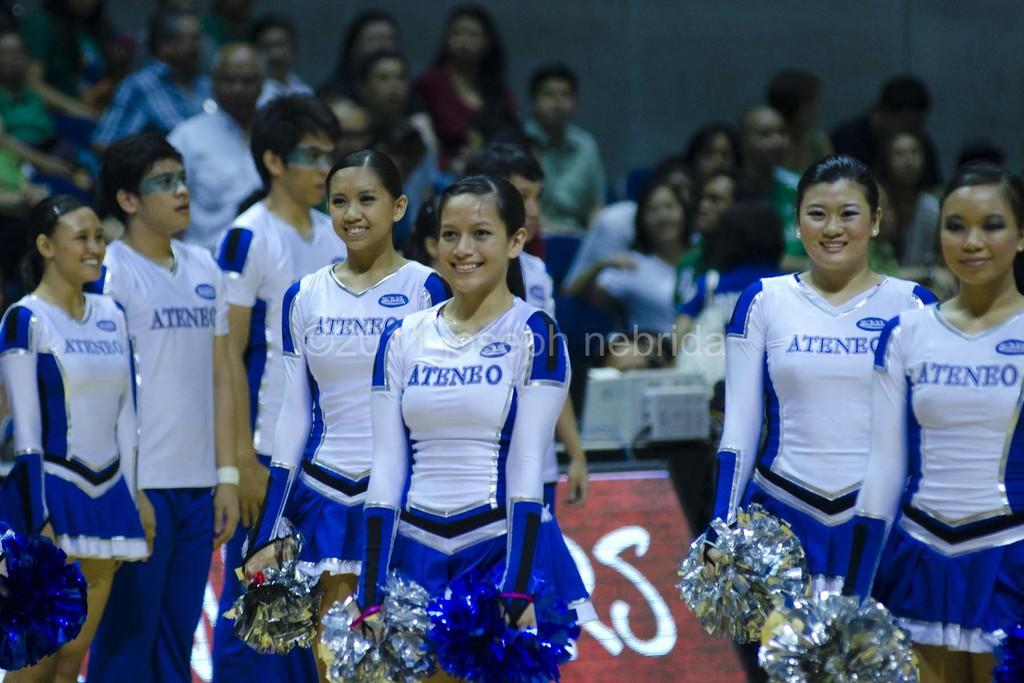What team are they cheering for?
Give a very brief answer. Ateneo. What is the team name for the cheerleaders?
Your response must be concise. Ateneo. 